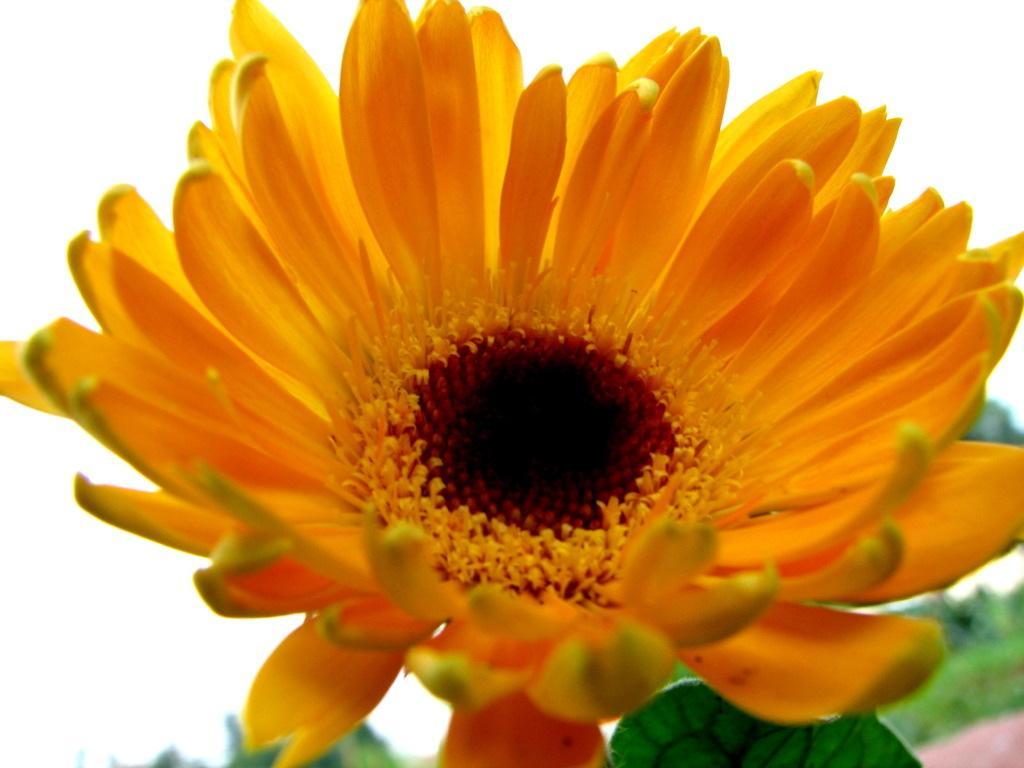How would you summarize this image in a sentence or two? In this picture we can see a flower and few leaves. 